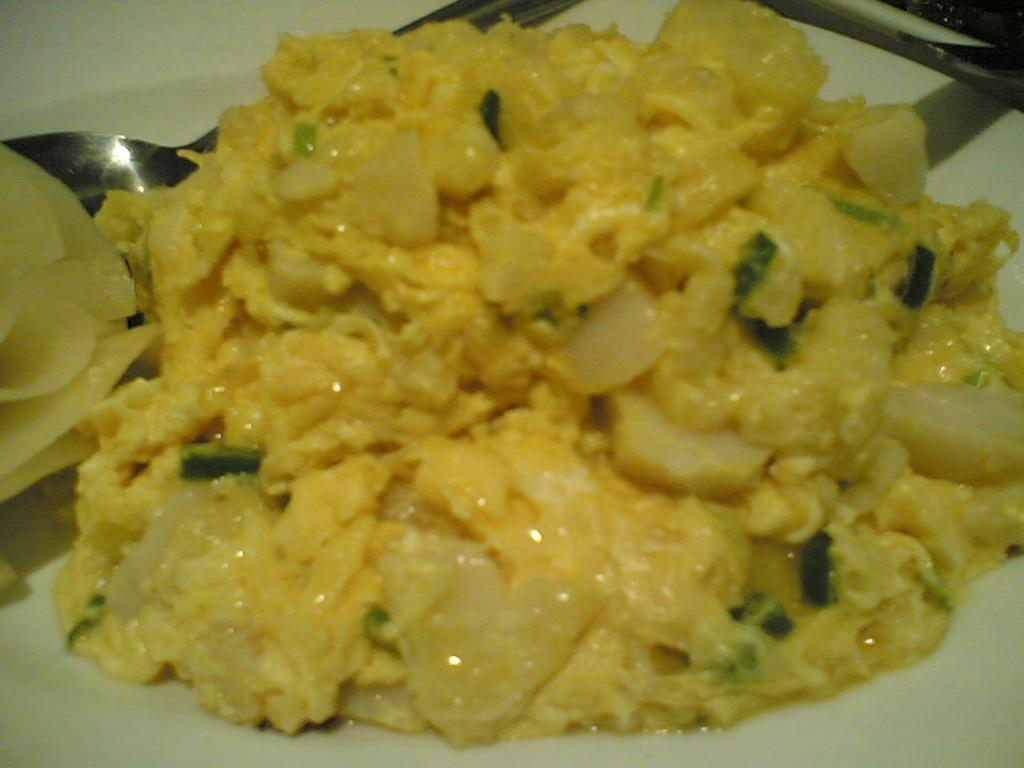What type of food is visible in the image? There is scrambled egg in the image. What is used for eating the food in the image? There is cutlery placed in a plate in the image. What type of poison is visible in the image? There is no poison present in the image; it features scrambled egg and cutlery. What type of worm can be seen crawling on the plate? There is no worm present in the image; it features scrambled egg and cutlery. 